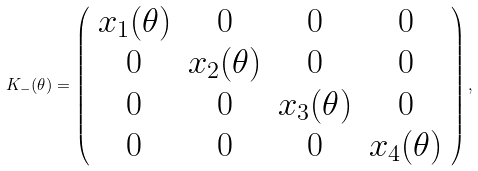<formula> <loc_0><loc_0><loc_500><loc_500>K _ { - } ( \theta ) = \left ( \begin{array} { c c c c } x _ { 1 } ( \theta ) & 0 & 0 & 0 \\ 0 & x _ { 2 } ( \theta ) & 0 & 0 \\ 0 & 0 & x _ { 3 } ( \theta ) & 0 \\ 0 & 0 & 0 & x _ { 4 } ( \theta ) \end{array} \right ) ,</formula> 